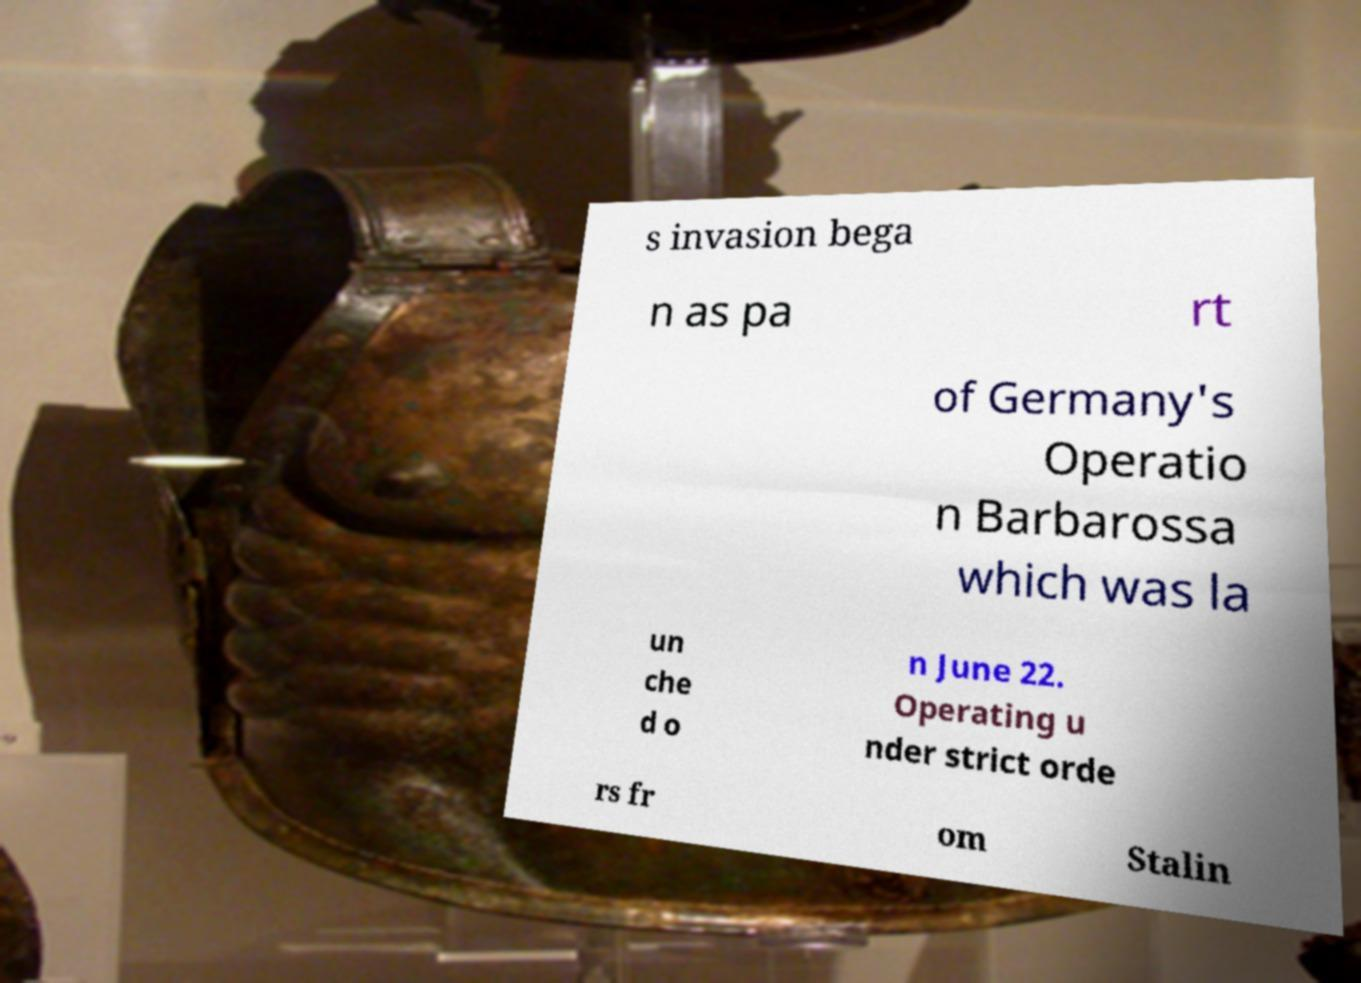For documentation purposes, I need the text within this image transcribed. Could you provide that? s invasion bega n as pa rt of Germany's Operatio n Barbarossa which was la un che d o n June 22. Operating u nder strict orde rs fr om Stalin 